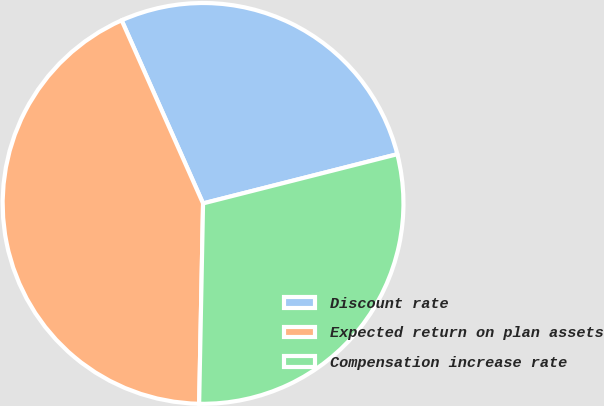Convert chart to OTSL. <chart><loc_0><loc_0><loc_500><loc_500><pie_chart><fcel>Discount rate<fcel>Expected return on plan assets<fcel>Compensation increase rate<nl><fcel>27.71%<fcel>43.03%<fcel>29.26%<nl></chart> 